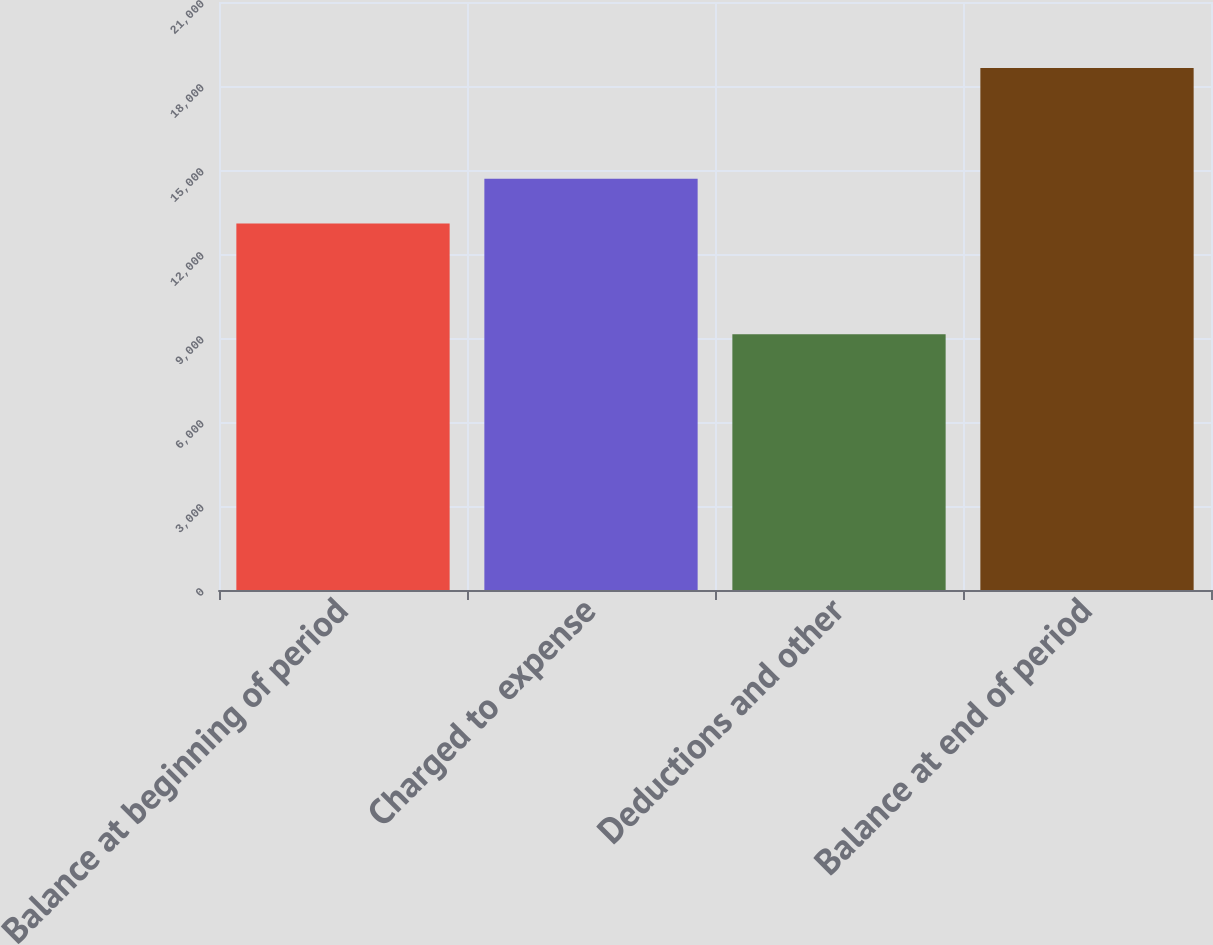<chart> <loc_0><loc_0><loc_500><loc_500><bar_chart><fcel>Balance at beginning of period<fcel>Charged to expense<fcel>Deductions and other<fcel>Balance at end of period<nl><fcel>13093<fcel>14688<fcel>9137<fcel>18644<nl></chart> 